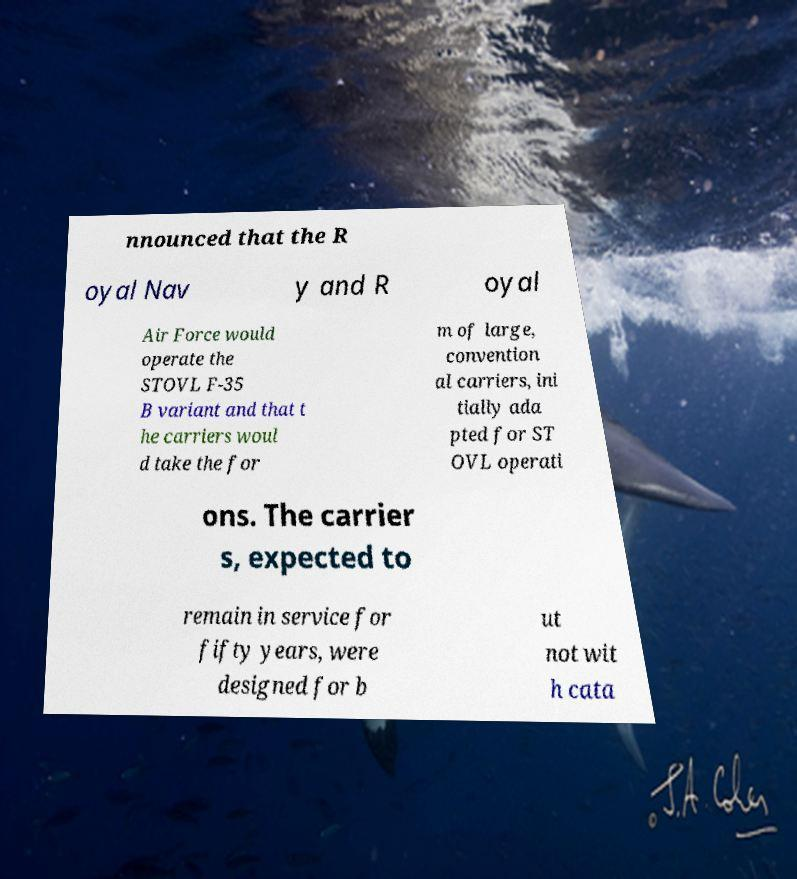What messages or text are displayed in this image? I need them in a readable, typed format. nnounced that the R oyal Nav y and R oyal Air Force would operate the STOVL F-35 B variant and that t he carriers woul d take the for m of large, convention al carriers, ini tially ada pted for ST OVL operati ons. The carrier s, expected to remain in service for fifty years, were designed for b ut not wit h cata 